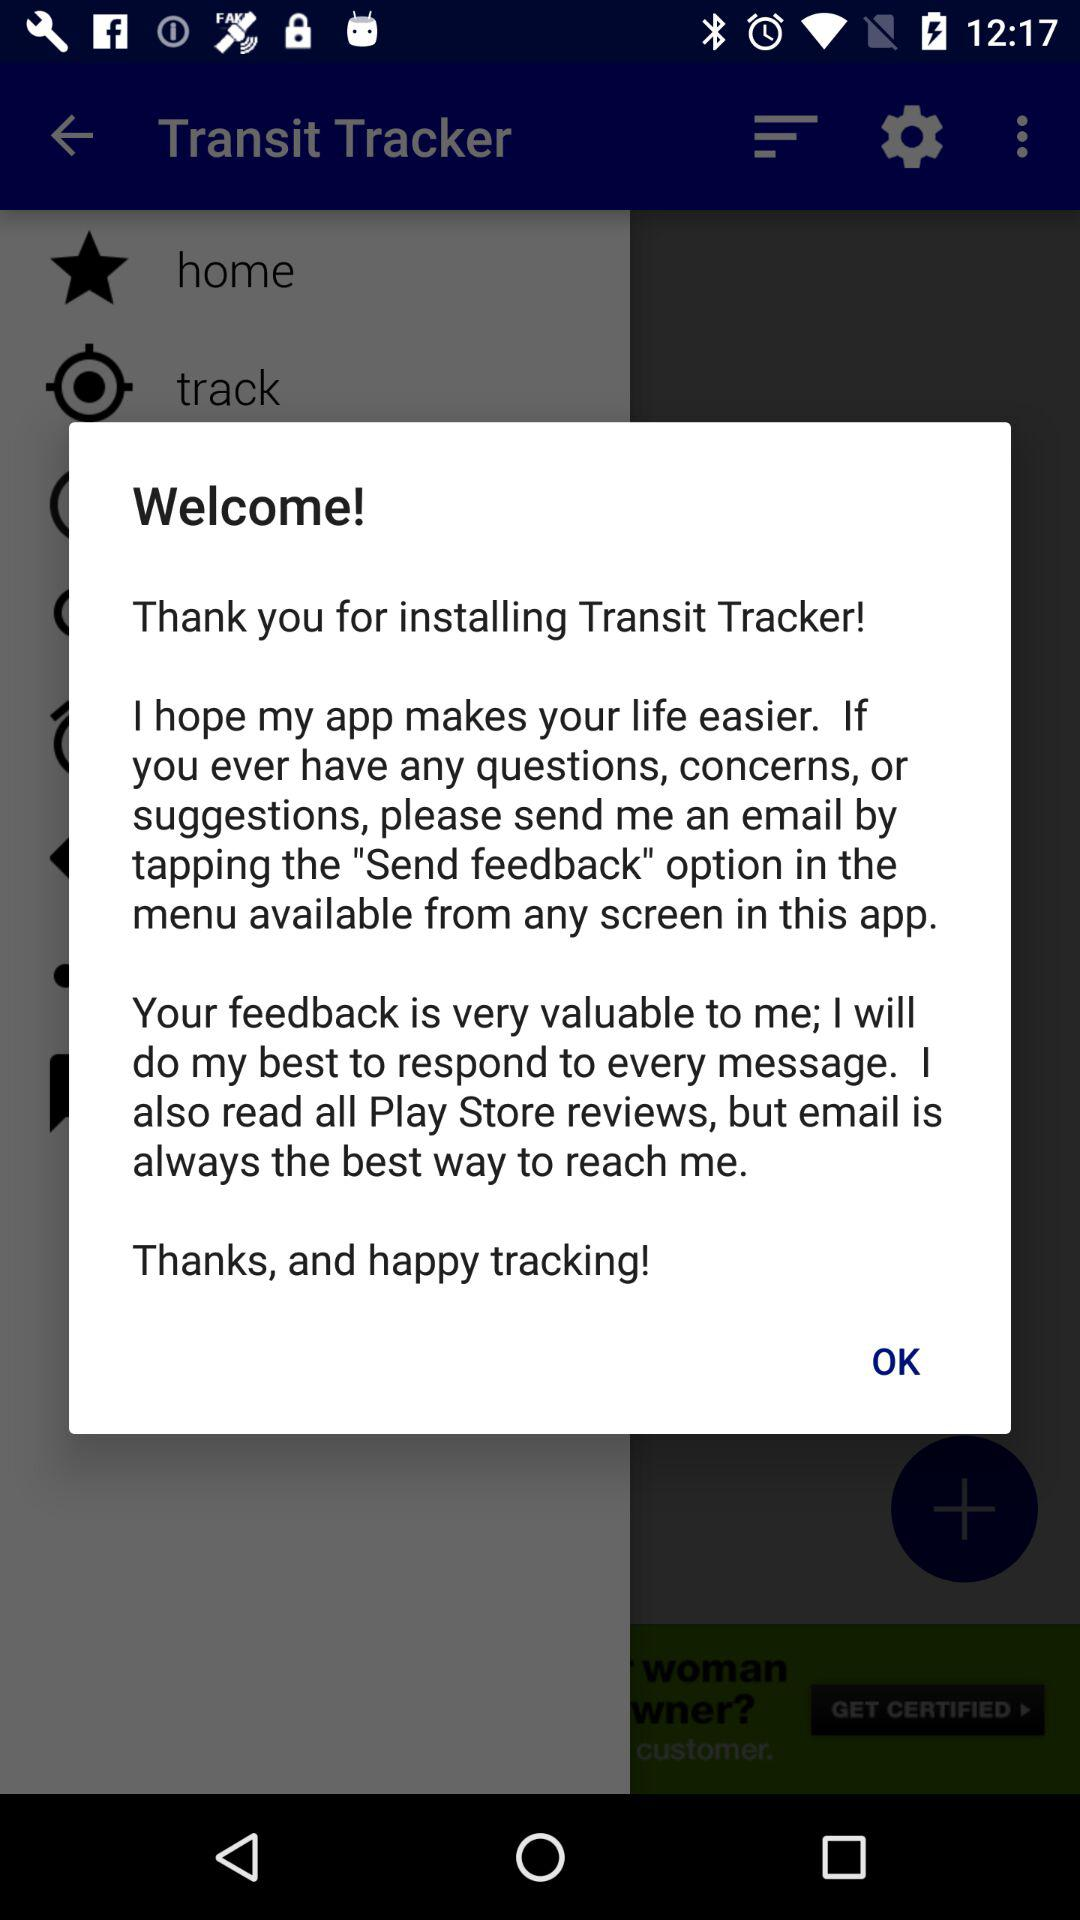What is the best way to reach the programmer? The best way to reach the programmer is email. 